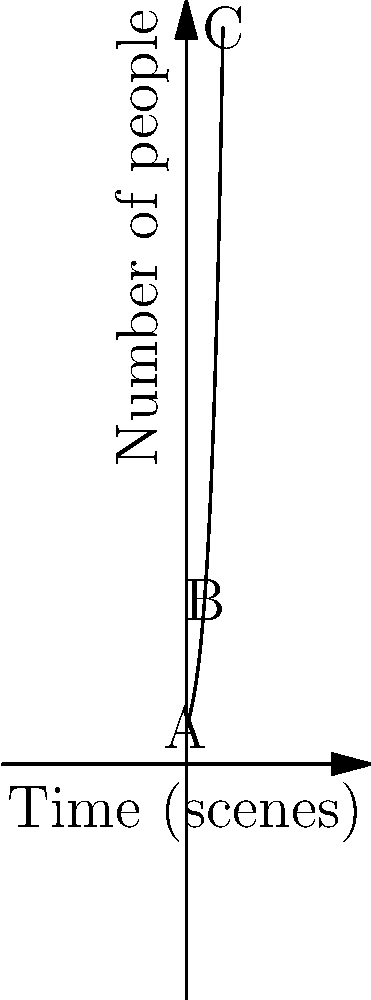In the film "Revolution's Echo," the director uses crowd scenes to represent the growth of a social movement. The graph shows the exponential increase in the number of people in these scenes over time. If point A represents 10 people, what is the approximate number of people at point C, and what does this progression symbolize in the context of historical films? To solve this problem, we need to follow these steps:

1) First, we recognize that the graph represents an exponential growth function of the form $f(x) = a \cdot e^{bx}$, where $a$ is the initial value and $b$ is the growth rate.

2) We're given that point A represents 10 people, so $a = 10$.

3) To find $b$, we can use the fact that the function passes through points A and C. Let's say C is at $x = 10$ on our scale.

4) The equation of the curve is thus: $f(x) = 10 \cdot e^{bx}$

5) At point C, $x = 10$, and visually we can estimate that $f(10)$ is about 200.

6) So we have: $200 \approx 10 \cdot e^{10b}$

7) Solving for $b$: 
   $20 \approx e^{10b}$
   $\ln(20) \approx 10b$
   $b \approx 0.3$

8) Therefore, the function is approximately $f(x) = 10 \cdot e^{0.3x}$

9) To find the exact value at C, we calculate:
   $f(10) = 10 \cdot e^{0.3 \cdot 10} \approx 201$

10) In the context of historical films, this exponential progression symbolizes the rapid growth and spread of social movements. It represents how ideas and activism can start with a small group and quickly expand to involve large portions of society, reflecting the often explosive nature of social change in history.
Answer: Approximately 201 people; symbolizes rapid growth of social movements in historical context. 